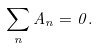Convert formula to latex. <formula><loc_0><loc_0><loc_500><loc_500>\sum _ { n } A _ { n } = 0 .</formula> 